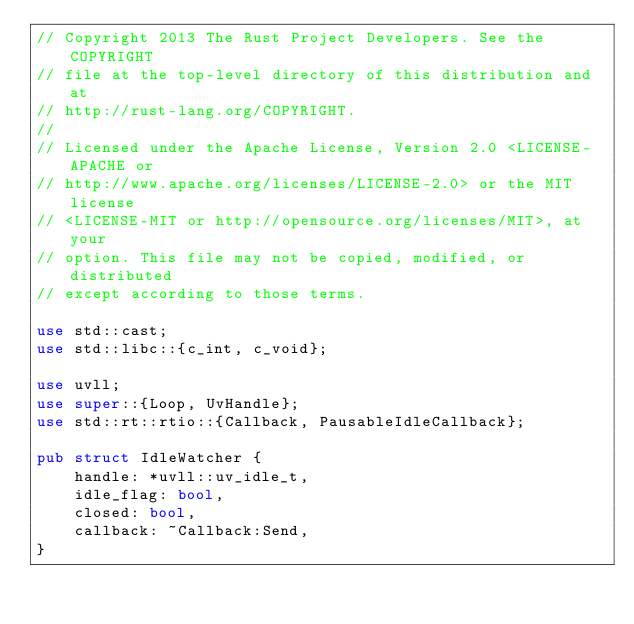<code> <loc_0><loc_0><loc_500><loc_500><_Rust_>// Copyright 2013 The Rust Project Developers. See the COPYRIGHT
// file at the top-level directory of this distribution and at
// http://rust-lang.org/COPYRIGHT.
//
// Licensed under the Apache License, Version 2.0 <LICENSE-APACHE or
// http://www.apache.org/licenses/LICENSE-2.0> or the MIT license
// <LICENSE-MIT or http://opensource.org/licenses/MIT>, at your
// option. This file may not be copied, modified, or distributed
// except according to those terms.

use std::cast;
use std::libc::{c_int, c_void};

use uvll;
use super::{Loop, UvHandle};
use std::rt::rtio::{Callback, PausableIdleCallback};

pub struct IdleWatcher {
    handle: *uvll::uv_idle_t,
    idle_flag: bool,
    closed: bool,
    callback: ~Callback:Send,
}
</code> 